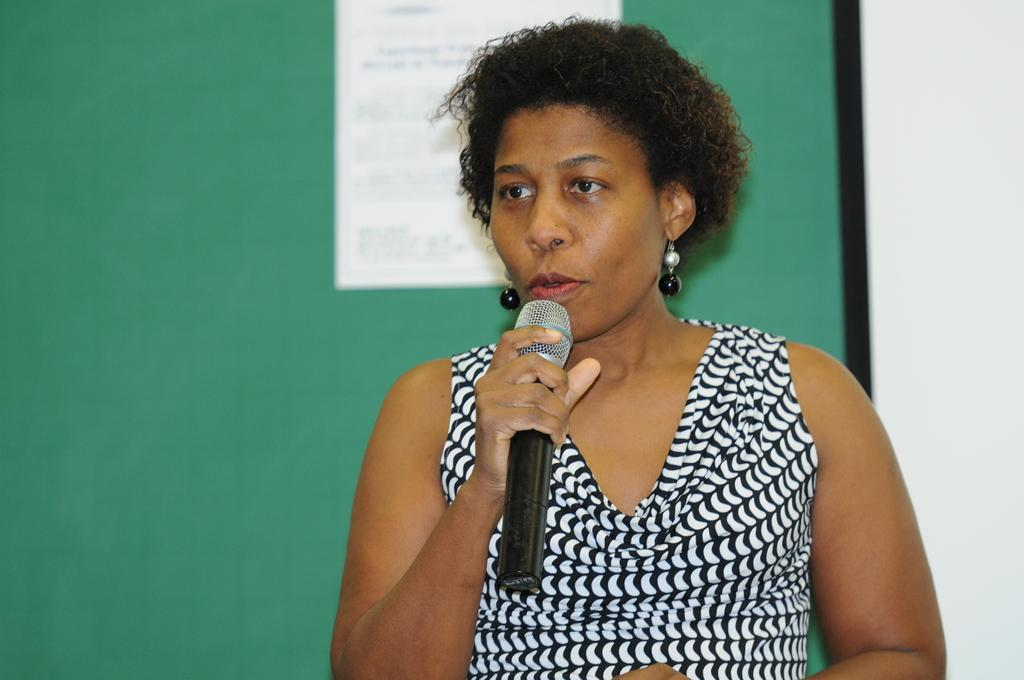Who is present in the image? There is a woman in the image. What is the woman wearing? The woman is wearing clothes and earrings. What is the woman holding in her hand? The woman is holding a microphone in her hand. What can be seen in the background of the image? The background of the image is blurred. What is attached to the wall in the image? There is a paper stick to the wall in the image. Can you see a pig or a beetle in the image? No, there is no pig or beetle present in the image. What type of room is shown in the image? The image does not show a room; it is focused on the woman and her surroundings. 